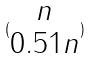<formula> <loc_0><loc_0><loc_500><loc_500>( \begin{matrix} n \\ 0 . 5 1 n \end{matrix} )</formula> 